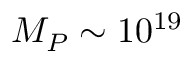<formula> <loc_0><loc_0><loc_500><loc_500>M _ { P } \sim 1 0 ^ { 1 9 }</formula> 